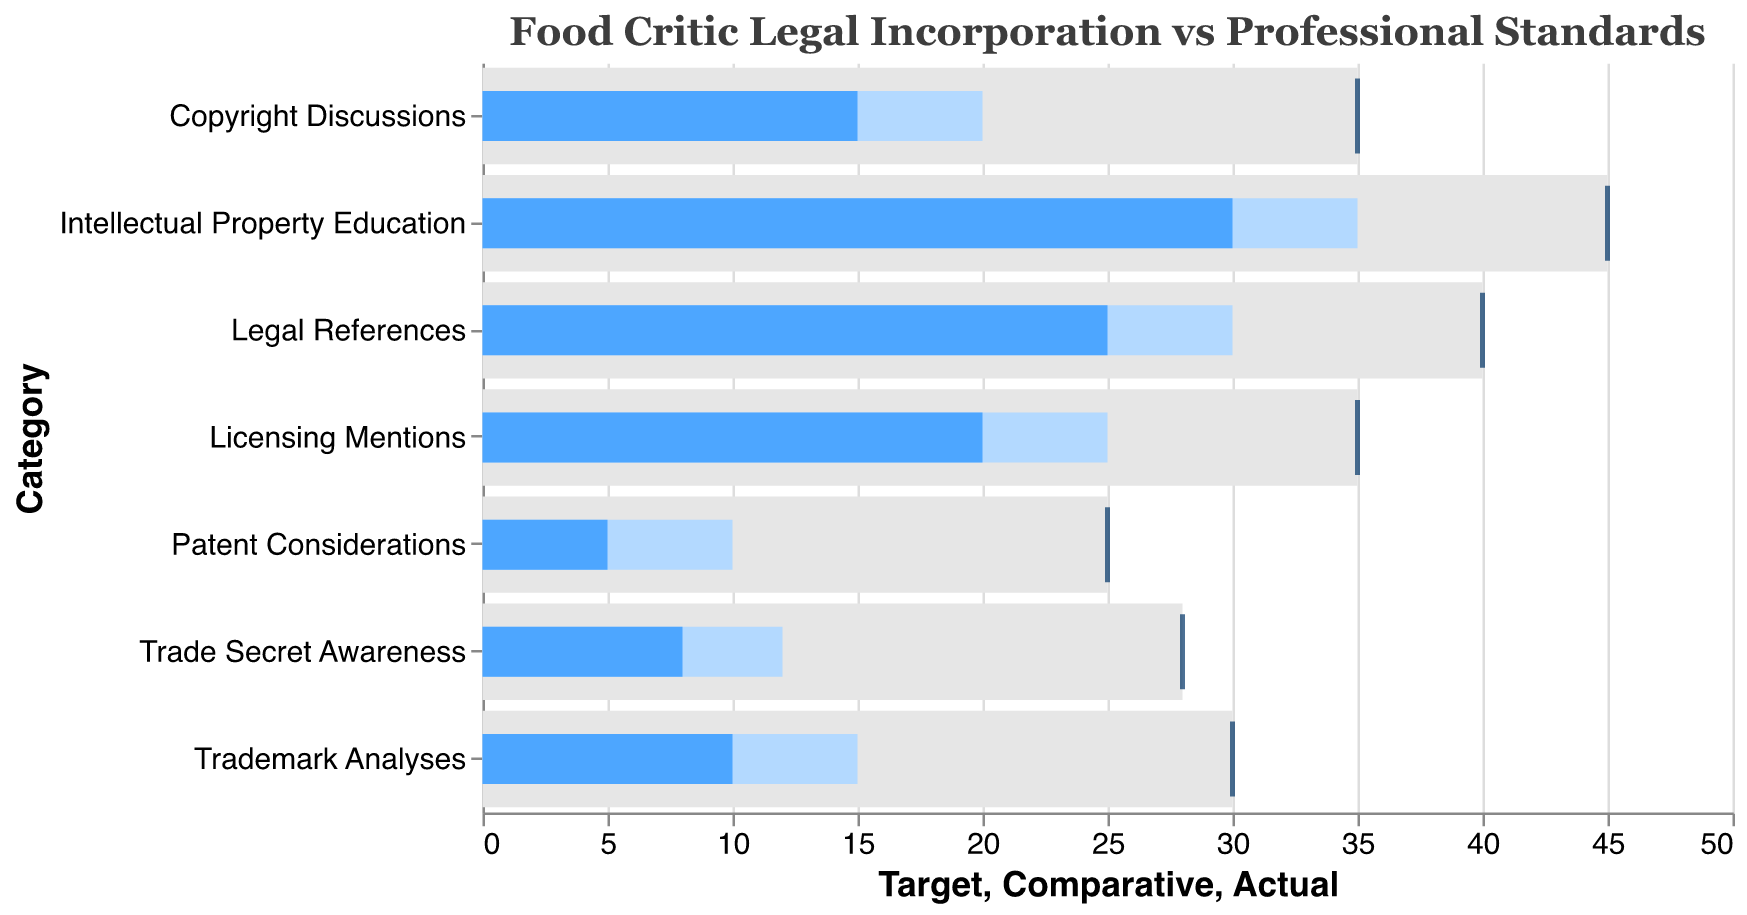What is the title of this figure? The title of the figure is displayed at the top of the chart in larger font and usually summarizes the main focus of the chart. It reads "Food Critic Legal Incorporation vs Professional Standards".
Answer: Food Critic Legal Incorporation vs Professional Standards In which category is the difference between the Actual and Target values the smallest? To find the smallest difference, subtract the Actual values from the Target values. The smallest difference is in the Intellectual Property Education category with a difference of 15 (45 - 30 = 15).
Answer: Intellectual Property Education What is the Actual percentage of food critics incorporating legal aspects in reviews for the 'Copyright Discussions' category? Locate the 'Copyright Discussions' category on the y-axis and read the Actual value represented by the blue bar. It is 15%.
Answer: 15% How does the actual incorporation for 'Patent Considerations' compare to its comparative and target standards? For 'Patent Considerations', the Actual value is 5%, the Comparative value is 10%, and the Target is 25%. To compare: Actual < Comparative < Target.
Answer: Actual < Comparative < Target Which category has the highest Actual value, and what is that value? Check all the blue bars for the Actual values, the highest Actual value is in the category 'Intellectual Property Education' with a value of 30%.
Answer: Intellectual Property Education, 30% What is the average of the comparative percentages across all categories? Sum all Comparative values (30 + 20 + 15 + 10 + 25 + 12 + 35) and divide by the number of categories, which is 7. The sum is 147 and the average is 147 / 7 = 21.
Answer: 21 Which category has the greatest gap between its Actual and Comparative values? Calculate the differences between Actual and Comparative values for each category: Legal References (5), Copyright Discussions (5), Trademark Analyses (5), Patent Considerations (5), Licensing Mentions (5), Trade Secret Awareness (4), Intellectual Property Education (5). Here, Legal References, Copyright Discussions, Trademark Analyses, Patent Considerations, Licensing Mentions, and Intellectual Property Education all have the greatest gap of 5.
Answer: Legal References, Copyright Discussions, Trademark Analyses, Patent Considerations, Licensing Mentions, Intellectual Property Education Is there any category where the Actual percentage meets or exceeds its Comparative value? Check each category to see if the Actual value (blue bar) is greater than or equal to the Comparative value. None of the Actual values meet or exceed their Comparative counterparts.
Answer: No What is the sum of Actual percentages for 'Trademark Analyses' and 'Trade Secret Awareness'? Add the Actual values for 'Trademark Analyses' (10) and 'Trade Secret Awareness' (8). The sum is 10 + 8 = 18.
Answer: 18 Compare the Actual and Target percentages for 'Licensing Mentions'. What is the difference? The Actual value for 'Licensing Mentions' is 20, and the Target value is 35. Their difference is 35 - 20 = 15.
Answer: 15 